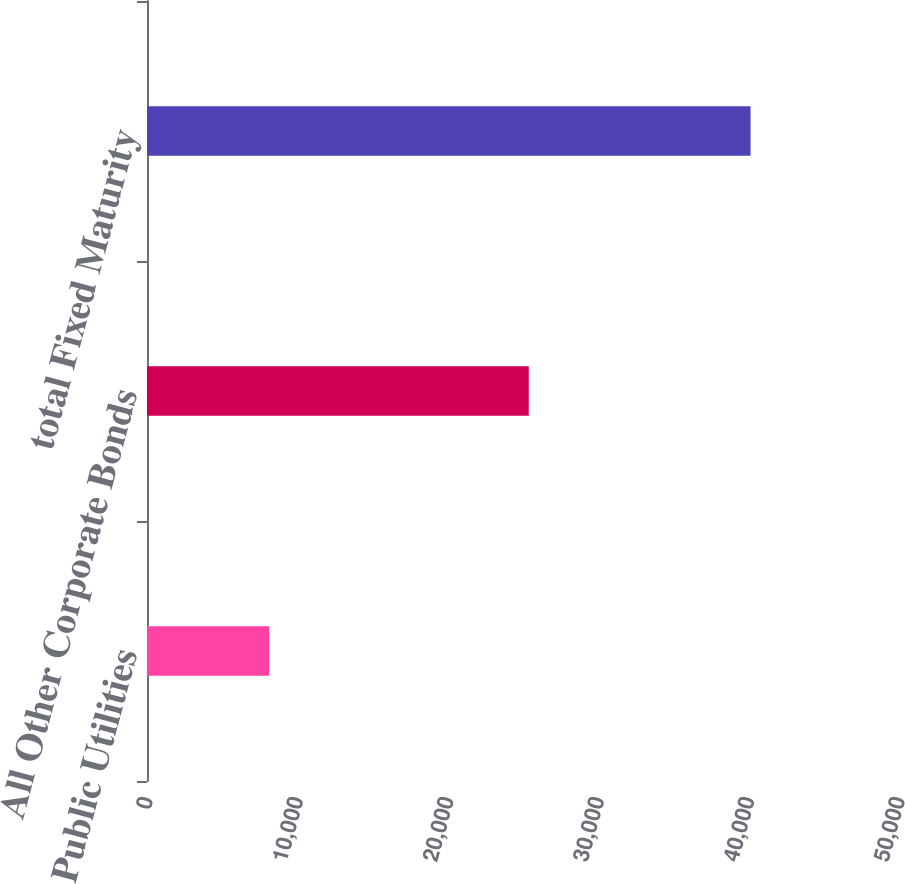Convert chart to OTSL. <chart><loc_0><loc_0><loc_500><loc_500><bar_chart><fcel>Public Utilities<fcel>All Other Corporate Bonds<fcel>total Fixed Maturity<nl><fcel>8129.4<fcel>25383.3<fcel>40130<nl></chart> 